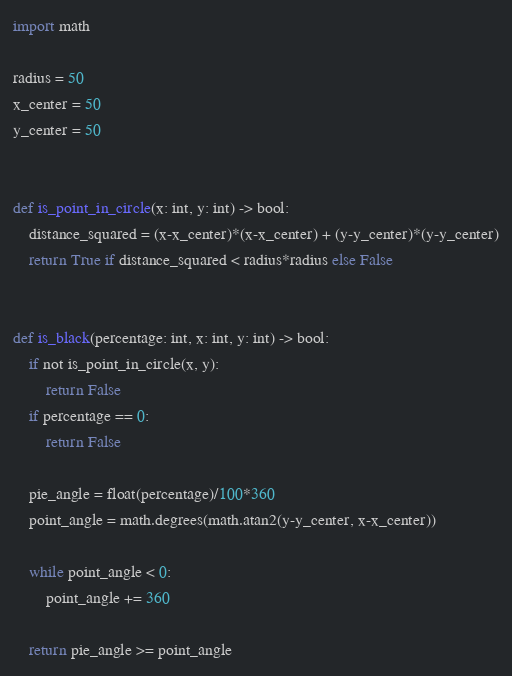Convert code to text. <code><loc_0><loc_0><loc_500><loc_500><_Python_>import math

radius = 50
x_center = 50
y_center = 50


def is_point_in_circle(x: int, y: int) -> bool:
    distance_squared = (x-x_center)*(x-x_center) + (y-y_center)*(y-y_center)
    return True if distance_squared < radius*radius else False


def is_black(percentage: int, x: int, y: int) -> bool:
    if not is_point_in_circle(x, y):
        return False
    if percentage == 0:
        return False

    pie_angle = float(percentage)/100*360
    point_angle = math.degrees(math.atan2(y-y_center, x-x_center))

    while point_angle < 0:
        point_angle += 360

    return pie_angle >= point_angle
</code> 